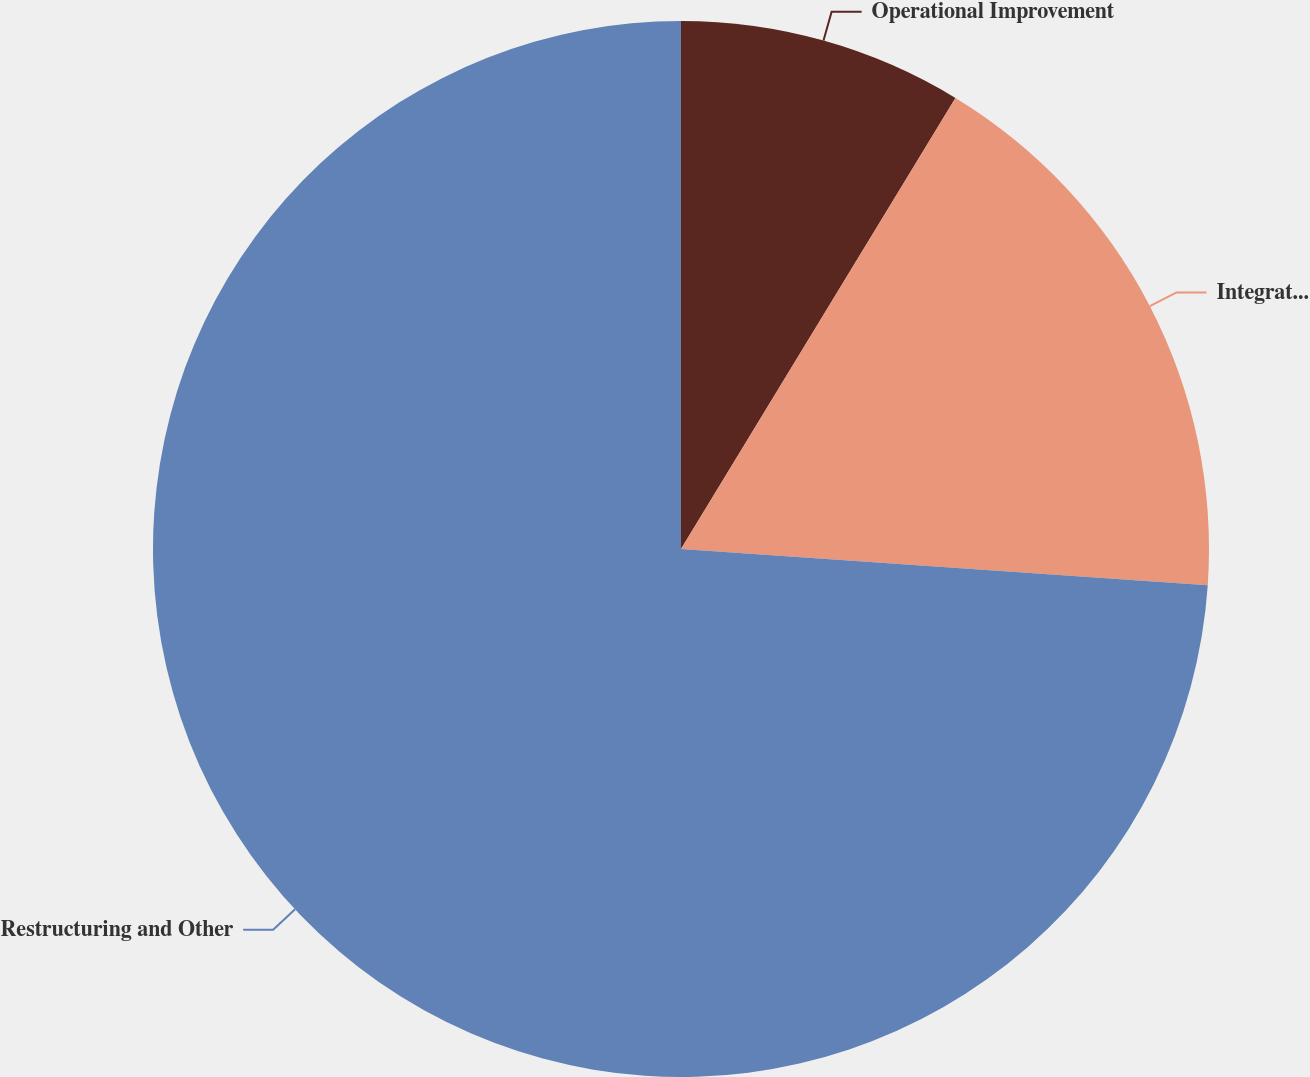<chart> <loc_0><loc_0><loc_500><loc_500><pie_chart><fcel>Operational Improvement<fcel>Integration Related Costs (c)<fcel>Restructuring and Other<nl><fcel>8.7%<fcel>17.39%<fcel>73.91%<nl></chart> 